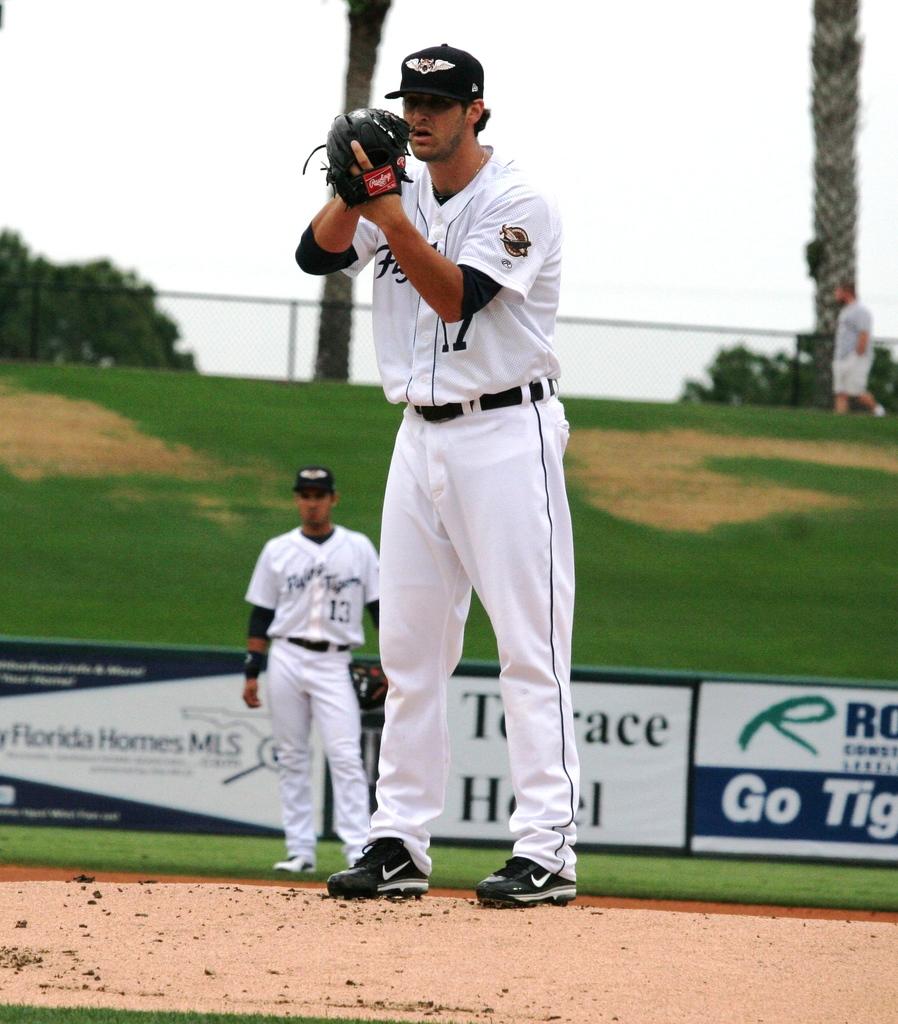What team name or city name is on the jerseys?
Make the answer very short. Unanswerable. What is the name of the hotel advertised in the back?
Give a very brief answer. Terrace hotel. 